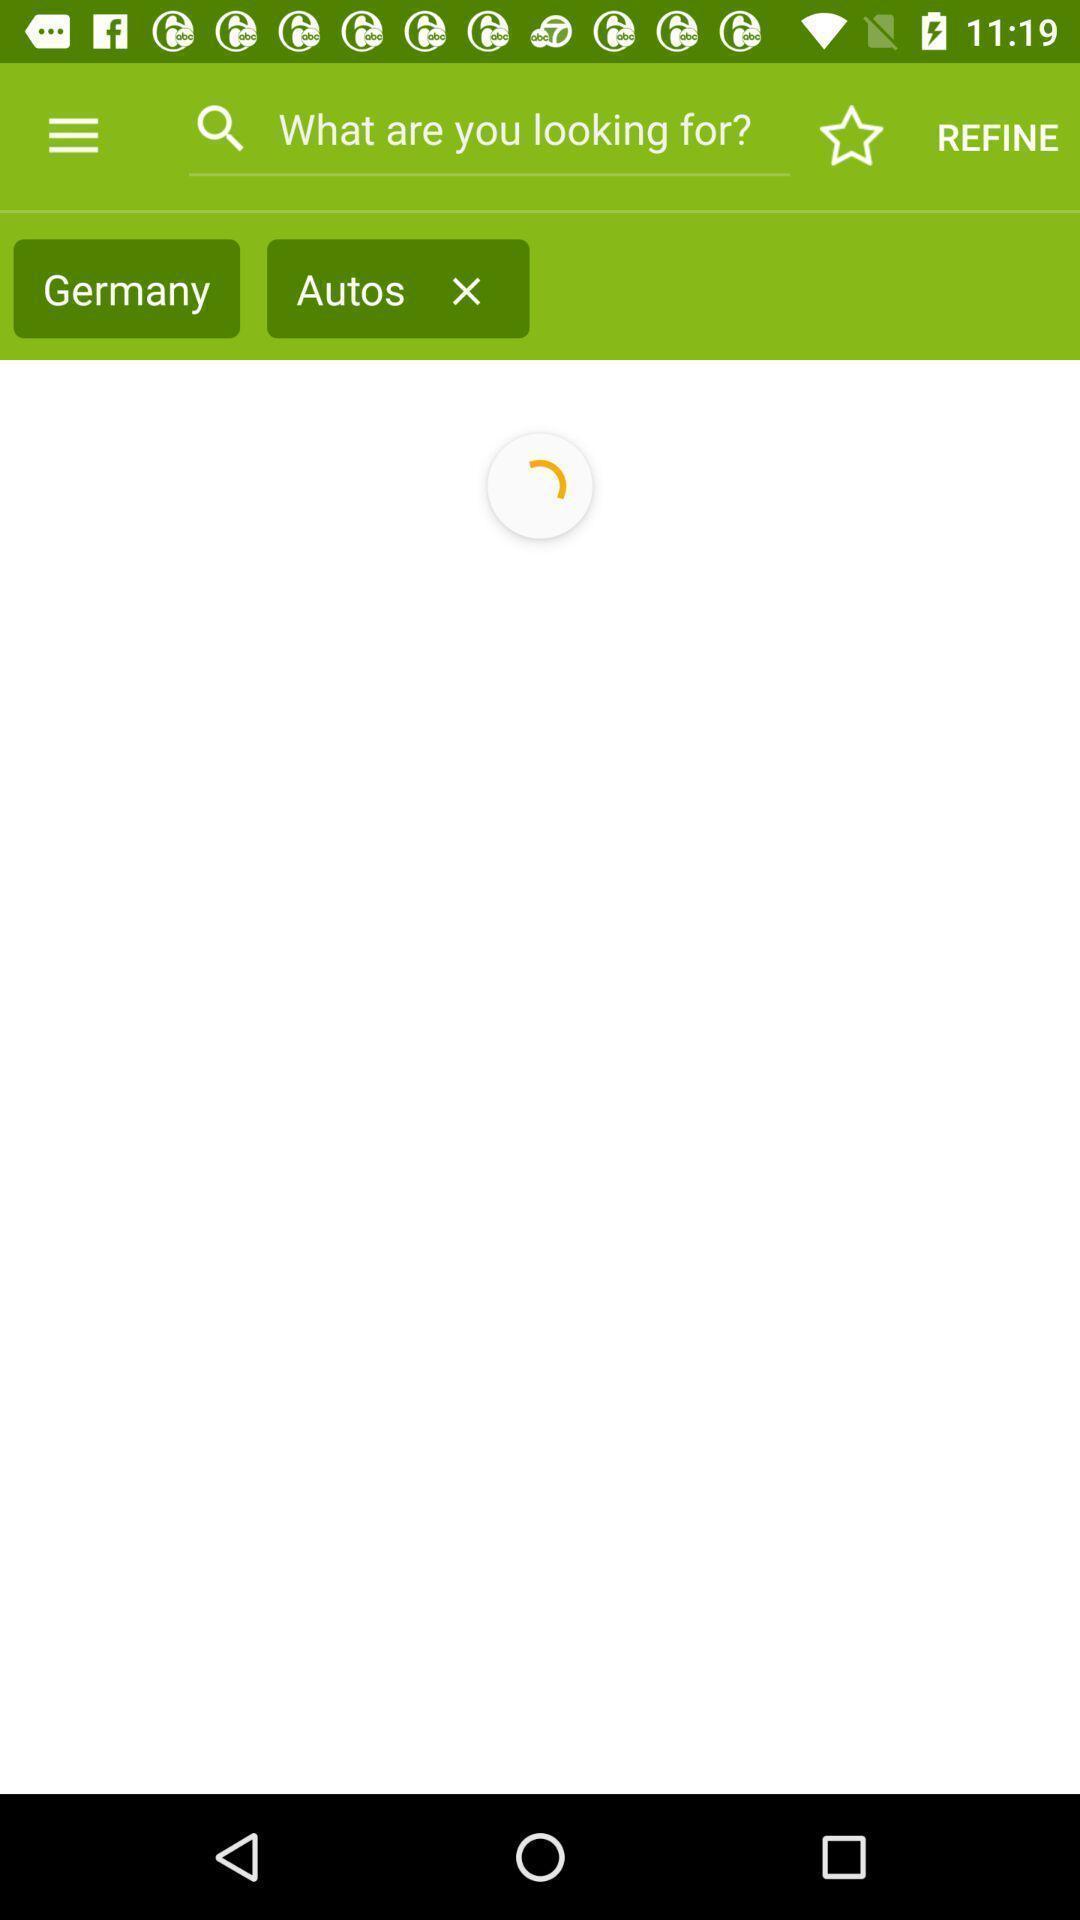Give me a summary of this screen capture. Page with search options in a classifieds app. 